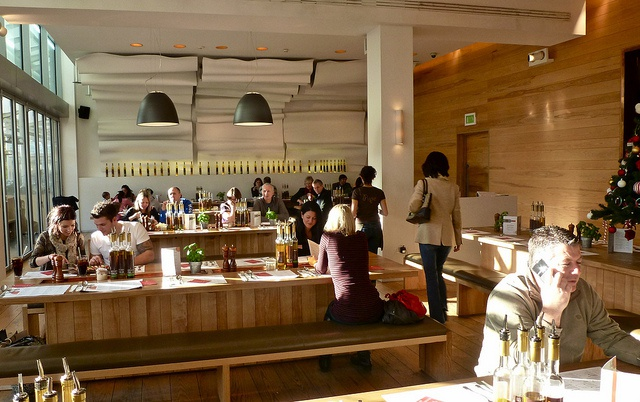Describe the objects in this image and their specific colors. I can see dining table in tan, maroon, lightgray, and gray tones, bench in tan, black, maroon, and olive tones, people in tan, white, gray, and maroon tones, bottle in tan, black, olive, and gray tones, and people in tan, black, maroon, and gray tones in this image. 